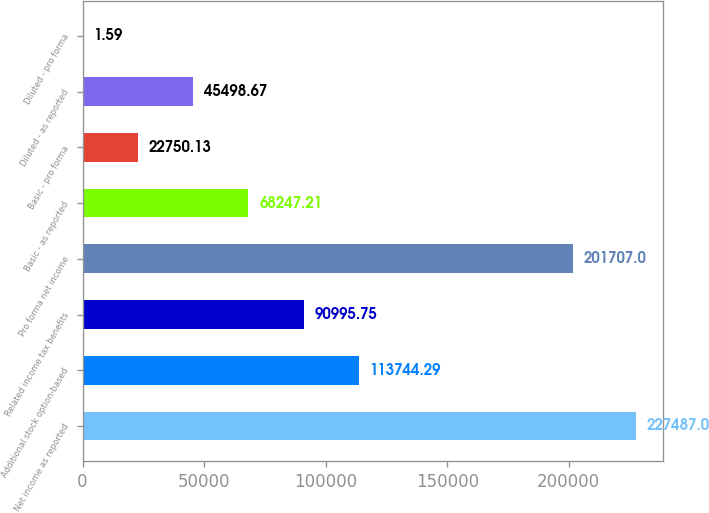<chart> <loc_0><loc_0><loc_500><loc_500><bar_chart><fcel>Net income as reported<fcel>Additional stock option-based<fcel>Related income tax benefits<fcel>Pro forma net income<fcel>Basic - as reported<fcel>Basic - pro forma<fcel>Diluted - as reported<fcel>Diluted - pro forma<nl><fcel>227487<fcel>113744<fcel>90995.8<fcel>201707<fcel>68247.2<fcel>22750.1<fcel>45498.7<fcel>1.59<nl></chart> 